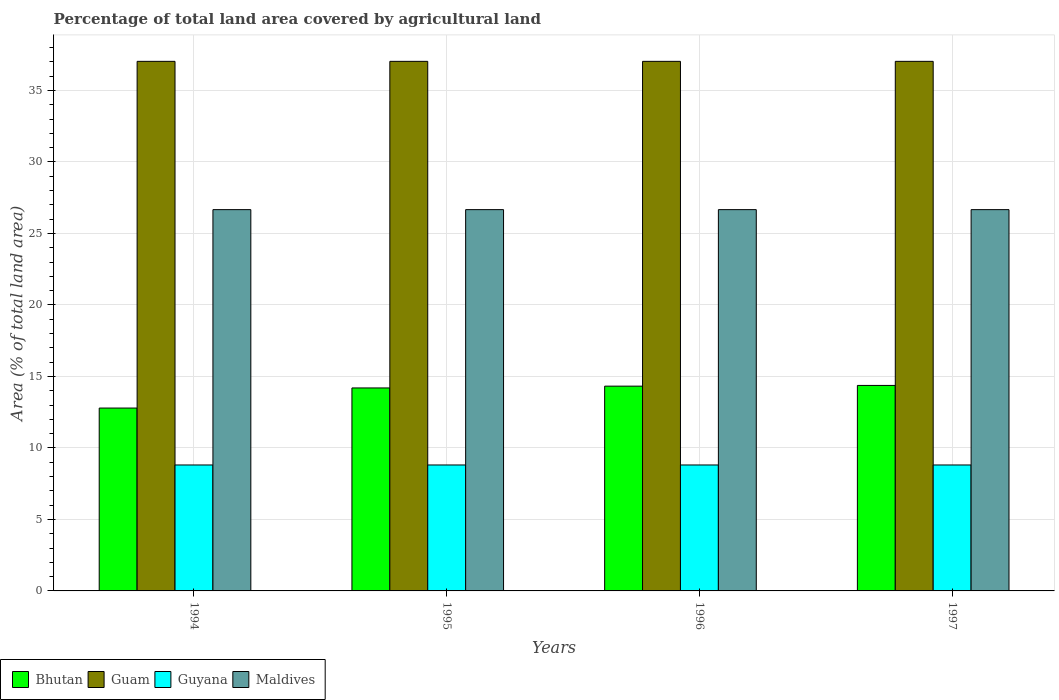How many groups of bars are there?
Give a very brief answer. 4. Are the number of bars per tick equal to the number of legend labels?
Provide a short and direct response. Yes. How many bars are there on the 3rd tick from the left?
Give a very brief answer. 4. What is the label of the 2nd group of bars from the left?
Offer a very short reply. 1995. What is the percentage of agricultural land in Guam in 1996?
Your answer should be compact. 37.04. Across all years, what is the maximum percentage of agricultural land in Maldives?
Offer a terse response. 26.67. Across all years, what is the minimum percentage of agricultural land in Guyana?
Offer a terse response. 8.81. In which year was the percentage of agricultural land in Maldives maximum?
Offer a terse response. 1994. In which year was the percentage of agricultural land in Bhutan minimum?
Keep it short and to the point. 1994. What is the total percentage of agricultural land in Maldives in the graph?
Ensure brevity in your answer.  106.67. What is the difference between the percentage of agricultural land in Bhutan in 1994 and that in 1997?
Your answer should be very brief. -1.58. What is the difference between the percentage of agricultural land in Maldives in 1997 and the percentage of agricultural land in Guam in 1996?
Give a very brief answer. -10.37. What is the average percentage of agricultural land in Guam per year?
Your response must be concise. 37.04. In the year 1996, what is the difference between the percentage of agricultural land in Guam and percentage of agricultural land in Bhutan?
Keep it short and to the point. 22.72. In how many years, is the percentage of agricultural land in Bhutan greater than 8 %?
Give a very brief answer. 4. What is the ratio of the percentage of agricultural land in Guam in 1996 to that in 1997?
Make the answer very short. 1. Is the percentage of agricultural land in Guyana in 1994 less than that in 1997?
Your response must be concise. No. What is the difference between the highest and the second highest percentage of agricultural land in Guyana?
Offer a terse response. 0. What is the difference between the highest and the lowest percentage of agricultural land in Bhutan?
Make the answer very short. 1.58. What does the 3rd bar from the left in 1995 represents?
Provide a short and direct response. Guyana. What does the 4th bar from the right in 1995 represents?
Your answer should be very brief. Bhutan. Is it the case that in every year, the sum of the percentage of agricultural land in Maldives and percentage of agricultural land in Guam is greater than the percentage of agricultural land in Bhutan?
Your response must be concise. Yes. Are all the bars in the graph horizontal?
Make the answer very short. No. Are the values on the major ticks of Y-axis written in scientific E-notation?
Your answer should be very brief. No. Does the graph contain any zero values?
Provide a short and direct response. No. Does the graph contain grids?
Your response must be concise. Yes. Where does the legend appear in the graph?
Your answer should be compact. Bottom left. How many legend labels are there?
Your answer should be very brief. 4. How are the legend labels stacked?
Offer a very short reply. Horizontal. What is the title of the graph?
Ensure brevity in your answer.  Percentage of total land area covered by agricultural land. What is the label or title of the Y-axis?
Provide a short and direct response. Area (% of total land area). What is the Area (% of total land area) of Bhutan in 1994?
Make the answer very short. 12.79. What is the Area (% of total land area) in Guam in 1994?
Keep it short and to the point. 37.04. What is the Area (% of total land area) of Guyana in 1994?
Ensure brevity in your answer.  8.81. What is the Area (% of total land area) in Maldives in 1994?
Your answer should be very brief. 26.67. What is the Area (% of total land area) of Bhutan in 1995?
Provide a short and direct response. 14.2. What is the Area (% of total land area) in Guam in 1995?
Your answer should be very brief. 37.04. What is the Area (% of total land area) of Guyana in 1995?
Provide a succinct answer. 8.81. What is the Area (% of total land area) in Maldives in 1995?
Your answer should be very brief. 26.67. What is the Area (% of total land area) of Bhutan in 1996?
Your answer should be compact. 14.32. What is the Area (% of total land area) of Guam in 1996?
Provide a succinct answer. 37.04. What is the Area (% of total land area) of Guyana in 1996?
Offer a terse response. 8.81. What is the Area (% of total land area) in Maldives in 1996?
Your answer should be very brief. 26.67. What is the Area (% of total land area) of Bhutan in 1997?
Make the answer very short. 14.37. What is the Area (% of total land area) of Guam in 1997?
Make the answer very short. 37.04. What is the Area (% of total land area) in Guyana in 1997?
Your answer should be compact. 8.81. What is the Area (% of total land area) in Maldives in 1997?
Offer a terse response. 26.67. Across all years, what is the maximum Area (% of total land area) of Bhutan?
Your response must be concise. 14.37. Across all years, what is the maximum Area (% of total land area) in Guam?
Offer a very short reply. 37.04. Across all years, what is the maximum Area (% of total land area) of Guyana?
Ensure brevity in your answer.  8.81. Across all years, what is the maximum Area (% of total land area) in Maldives?
Give a very brief answer. 26.67. Across all years, what is the minimum Area (% of total land area) in Bhutan?
Provide a short and direct response. 12.79. Across all years, what is the minimum Area (% of total land area) in Guam?
Your answer should be compact. 37.04. Across all years, what is the minimum Area (% of total land area) of Guyana?
Provide a succinct answer. 8.81. Across all years, what is the minimum Area (% of total land area) of Maldives?
Provide a succinct answer. 26.67. What is the total Area (% of total land area) of Bhutan in the graph?
Give a very brief answer. 55.68. What is the total Area (% of total land area) of Guam in the graph?
Your answer should be very brief. 148.15. What is the total Area (% of total land area) of Guyana in the graph?
Your answer should be compact. 35.23. What is the total Area (% of total land area) in Maldives in the graph?
Offer a very short reply. 106.67. What is the difference between the Area (% of total land area) of Bhutan in 1994 and that in 1995?
Provide a succinct answer. -1.41. What is the difference between the Area (% of total land area) of Guyana in 1994 and that in 1995?
Your answer should be very brief. 0. What is the difference between the Area (% of total land area) of Maldives in 1994 and that in 1995?
Keep it short and to the point. 0. What is the difference between the Area (% of total land area) in Bhutan in 1994 and that in 1996?
Your response must be concise. -1.53. What is the difference between the Area (% of total land area) in Maldives in 1994 and that in 1996?
Make the answer very short. 0. What is the difference between the Area (% of total land area) in Bhutan in 1994 and that in 1997?
Keep it short and to the point. -1.58. What is the difference between the Area (% of total land area) of Guam in 1994 and that in 1997?
Give a very brief answer. 0. What is the difference between the Area (% of total land area) in Bhutan in 1995 and that in 1996?
Give a very brief answer. -0.13. What is the difference between the Area (% of total land area) in Guyana in 1995 and that in 1996?
Your response must be concise. 0. What is the difference between the Area (% of total land area) of Bhutan in 1995 and that in 1997?
Your answer should be very brief. -0.18. What is the difference between the Area (% of total land area) in Guam in 1995 and that in 1997?
Offer a very short reply. 0. What is the difference between the Area (% of total land area) in Maldives in 1995 and that in 1997?
Give a very brief answer. 0. What is the difference between the Area (% of total land area) in Bhutan in 1996 and that in 1997?
Your response must be concise. -0.05. What is the difference between the Area (% of total land area) of Maldives in 1996 and that in 1997?
Ensure brevity in your answer.  0. What is the difference between the Area (% of total land area) of Bhutan in 1994 and the Area (% of total land area) of Guam in 1995?
Your answer should be very brief. -24.25. What is the difference between the Area (% of total land area) of Bhutan in 1994 and the Area (% of total land area) of Guyana in 1995?
Make the answer very short. 3.98. What is the difference between the Area (% of total land area) of Bhutan in 1994 and the Area (% of total land area) of Maldives in 1995?
Offer a terse response. -13.88. What is the difference between the Area (% of total land area) of Guam in 1994 and the Area (% of total land area) of Guyana in 1995?
Give a very brief answer. 28.23. What is the difference between the Area (% of total land area) in Guam in 1994 and the Area (% of total land area) in Maldives in 1995?
Offer a very short reply. 10.37. What is the difference between the Area (% of total land area) in Guyana in 1994 and the Area (% of total land area) in Maldives in 1995?
Offer a terse response. -17.86. What is the difference between the Area (% of total land area) in Bhutan in 1994 and the Area (% of total land area) in Guam in 1996?
Provide a succinct answer. -24.25. What is the difference between the Area (% of total land area) of Bhutan in 1994 and the Area (% of total land area) of Guyana in 1996?
Give a very brief answer. 3.98. What is the difference between the Area (% of total land area) of Bhutan in 1994 and the Area (% of total land area) of Maldives in 1996?
Offer a very short reply. -13.88. What is the difference between the Area (% of total land area) in Guam in 1994 and the Area (% of total land area) in Guyana in 1996?
Your answer should be very brief. 28.23. What is the difference between the Area (% of total land area) of Guam in 1994 and the Area (% of total land area) of Maldives in 1996?
Keep it short and to the point. 10.37. What is the difference between the Area (% of total land area) in Guyana in 1994 and the Area (% of total land area) in Maldives in 1996?
Ensure brevity in your answer.  -17.86. What is the difference between the Area (% of total land area) of Bhutan in 1994 and the Area (% of total land area) of Guam in 1997?
Your response must be concise. -24.25. What is the difference between the Area (% of total land area) in Bhutan in 1994 and the Area (% of total land area) in Guyana in 1997?
Your answer should be compact. 3.98. What is the difference between the Area (% of total land area) in Bhutan in 1994 and the Area (% of total land area) in Maldives in 1997?
Your answer should be compact. -13.88. What is the difference between the Area (% of total land area) in Guam in 1994 and the Area (% of total land area) in Guyana in 1997?
Provide a succinct answer. 28.23. What is the difference between the Area (% of total land area) in Guam in 1994 and the Area (% of total land area) in Maldives in 1997?
Give a very brief answer. 10.37. What is the difference between the Area (% of total land area) in Guyana in 1994 and the Area (% of total land area) in Maldives in 1997?
Provide a succinct answer. -17.86. What is the difference between the Area (% of total land area) of Bhutan in 1995 and the Area (% of total land area) of Guam in 1996?
Provide a short and direct response. -22.84. What is the difference between the Area (% of total land area) of Bhutan in 1995 and the Area (% of total land area) of Guyana in 1996?
Your response must be concise. 5.39. What is the difference between the Area (% of total land area) in Bhutan in 1995 and the Area (% of total land area) in Maldives in 1996?
Offer a terse response. -12.47. What is the difference between the Area (% of total land area) in Guam in 1995 and the Area (% of total land area) in Guyana in 1996?
Ensure brevity in your answer.  28.23. What is the difference between the Area (% of total land area) in Guam in 1995 and the Area (% of total land area) in Maldives in 1996?
Provide a short and direct response. 10.37. What is the difference between the Area (% of total land area) in Guyana in 1995 and the Area (% of total land area) in Maldives in 1996?
Provide a succinct answer. -17.86. What is the difference between the Area (% of total land area) of Bhutan in 1995 and the Area (% of total land area) of Guam in 1997?
Offer a terse response. -22.84. What is the difference between the Area (% of total land area) in Bhutan in 1995 and the Area (% of total land area) in Guyana in 1997?
Offer a very short reply. 5.39. What is the difference between the Area (% of total land area) of Bhutan in 1995 and the Area (% of total land area) of Maldives in 1997?
Provide a succinct answer. -12.47. What is the difference between the Area (% of total land area) of Guam in 1995 and the Area (% of total land area) of Guyana in 1997?
Offer a very short reply. 28.23. What is the difference between the Area (% of total land area) of Guam in 1995 and the Area (% of total land area) of Maldives in 1997?
Make the answer very short. 10.37. What is the difference between the Area (% of total land area) in Guyana in 1995 and the Area (% of total land area) in Maldives in 1997?
Provide a succinct answer. -17.86. What is the difference between the Area (% of total land area) in Bhutan in 1996 and the Area (% of total land area) in Guam in 1997?
Your response must be concise. -22.72. What is the difference between the Area (% of total land area) in Bhutan in 1996 and the Area (% of total land area) in Guyana in 1997?
Your answer should be compact. 5.51. What is the difference between the Area (% of total land area) of Bhutan in 1996 and the Area (% of total land area) of Maldives in 1997?
Your answer should be very brief. -12.35. What is the difference between the Area (% of total land area) in Guam in 1996 and the Area (% of total land area) in Guyana in 1997?
Keep it short and to the point. 28.23. What is the difference between the Area (% of total land area) in Guam in 1996 and the Area (% of total land area) in Maldives in 1997?
Your response must be concise. 10.37. What is the difference between the Area (% of total land area) of Guyana in 1996 and the Area (% of total land area) of Maldives in 1997?
Offer a terse response. -17.86. What is the average Area (% of total land area) in Bhutan per year?
Your answer should be very brief. 13.92. What is the average Area (% of total land area) in Guam per year?
Your answer should be very brief. 37.04. What is the average Area (% of total land area) in Guyana per year?
Your answer should be compact. 8.81. What is the average Area (% of total land area) in Maldives per year?
Provide a short and direct response. 26.67. In the year 1994, what is the difference between the Area (% of total land area) of Bhutan and Area (% of total land area) of Guam?
Ensure brevity in your answer.  -24.25. In the year 1994, what is the difference between the Area (% of total land area) of Bhutan and Area (% of total land area) of Guyana?
Ensure brevity in your answer.  3.98. In the year 1994, what is the difference between the Area (% of total land area) in Bhutan and Area (% of total land area) in Maldives?
Provide a succinct answer. -13.88. In the year 1994, what is the difference between the Area (% of total land area) of Guam and Area (% of total land area) of Guyana?
Provide a succinct answer. 28.23. In the year 1994, what is the difference between the Area (% of total land area) of Guam and Area (% of total land area) of Maldives?
Your answer should be very brief. 10.37. In the year 1994, what is the difference between the Area (% of total land area) in Guyana and Area (% of total land area) in Maldives?
Keep it short and to the point. -17.86. In the year 1995, what is the difference between the Area (% of total land area) of Bhutan and Area (% of total land area) of Guam?
Offer a terse response. -22.84. In the year 1995, what is the difference between the Area (% of total land area) of Bhutan and Area (% of total land area) of Guyana?
Offer a terse response. 5.39. In the year 1995, what is the difference between the Area (% of total land area) of Bhutan and Area (% of total land area) of Maldives?
Make the answer very short. -12.47. In the year 1995, what is the difference between the Area (% of total land area) in Guam and Area (% of total land area) in Guyana?
Offer a terse response. 28.23. In the year 1995, what is the difference between the Area (% of total land area) in Guam and Area (% of total land area) in Maldives?
Your answer should be compact. 10.37. In the year 1995, what is the difference between the Area (% of total land area) in Guyana and Area (% of total land area) in Maldives?
Your answer should be compact. -17.86. In the year 1996, what is the difference between the Area (% of total land area) in Bhutan and Area (% of total land area) in Guam?
Make the answer very short. -22.72. In the year 1996, what is the difference between the Area (% of total land area) in Bhutan and Area (% of total land area) in Guyana?
Your answer should be compact. 5.51. In the year 1996, what is the difference between the Area (% of total land area) of Bhutan and Area (% of total land area) of Maldives?
Offer a very short reply. -12.35. In the year 1996, what is the difference between the Area (% of total land area) in Guam and Area (% of total land area) in Guyana?
Offer a terse response. 28.23. In the year 1996, what is the difference between the Area (% of total land area) of Guam and Area (% of total land area) of Maldives?
Give a very brief answer. 10.37. In the year 1996, what is the difference between the Area (% of total land area) in Guyana and Area (% of total land area) in Maldives?
Offer a terse response. -17.86. In the year 1997, what is the difference between the Area (% of total land area) in Bhutan and Area (% of total land area) in Guam?
Make the answer very short. -22.67. In the year 1997, what is the difference between the Area (% of total land area) in Bhutan and Area (% of total land area) in Guyana?
Ensure brevity in your answer.  5.56. In the year 1997, what is the difference between the Area (% of total land area) in Bhutan and Area (% of total land area) in Maldives?
Your response must be concise. -12.29. In the year 1997, what is the difference between the Area (% of total land area) in Guam and Area (% of total land area) in Guyana?
Your response must be concise. 28.23. In the year 1997, what is the difference between the Area (% of total land area) of Guam and Area (% of total land area) of Maldives?
Your answer should be compact. 10.37. In the year 1997, what is the difference between the Area (% of total land area) in Guyana and Area (% of total land area) in Maldives?
Provide a succinct answer. -17.86. What is the ratio of the Area (% of total land area) in Bhutan in 1994 to that in 1995?
Offer a terse response. 0.9. What is the ratio of the Area (% of total land area) of Guam in 1994 to that in 1995?
Your answer should be compact. 1. What is the ratio of the Area (% of total land area) of Guyana in 1994 to that in 1995?
Offer a very short reply. 1. What is the ratio of the Area (% of total land area) of Bhutan in 1994 to that in 1996?
Your response must be concise. 0.89. What is the ratio of the Area (% of total land area) of Guam in 1994 to that in 1996?
Provide a short and direct response. 1. What is the ratio of the Area (% of total land area) of Guyana in 1994 to that in 1996?
Your answer should be compact. 1. What is the ratio of the Area (% of total land area) in Maldives in 1994 to that in 1996?
Offer a very short reply. 1. What is the ratio of the Area (% of total land area) of Bhutan in 1994 to that in 1997?
Your answer should be very brief. 0.89. What is the ratio of the Area (% of total land area) in Guam in 1994 to that in 1997?
Your answer should be compact. 1. What is the ratio of the Area (% of total land area) in Maldives in 1994 to that in 1997?
Make the answer very short. 1. What is the ratio of the Area (% of total land area) of Bhutan in 1995 to that in 1996?
Provide a succinct answer. 0.99. What is the ratio of the Area (% of total land area) in Guam in 1995 to that in 1996?
Give a very brief answer. 1. What is the ratio of the Area (% of total land area) in Guyana in 1995 to that in 1996?
Make the answer very short. 1. What is the ratio of the Area (% of total land area) of Bhutan in 1995 to that in 1997?
Keep it short and to the point. 0.99. What is the ratio of the Area (% of total land area) in Maldives in 1995 to that in 1997?
Your answer should be compact. 1. What is the ratio of the Area (% of total land area) of Bhutan in 1996 to that in 1997?
Your answer should be very brief. 1. What is the ratio of the Area (% of total land area) of Maldives in 1996 to that in 1997?
Give a very brief answer. 1. What is the difference between the highest and the second highest Area (% of total land area) in Bhutan?
Offer a very short reply. 0.05. What is the difference between the highest and the second highest Area (% of total land area) in Guam?
Your answer should be compact. 0. What is the difference between the highest and the lowest Area (% of total land area) of Bhutan?
Ensure brevity in your answer.  1.58. What is the difference between the highest and the lowest Area (% of total land area) of Guyana?
Offer a very short reply. 0. 